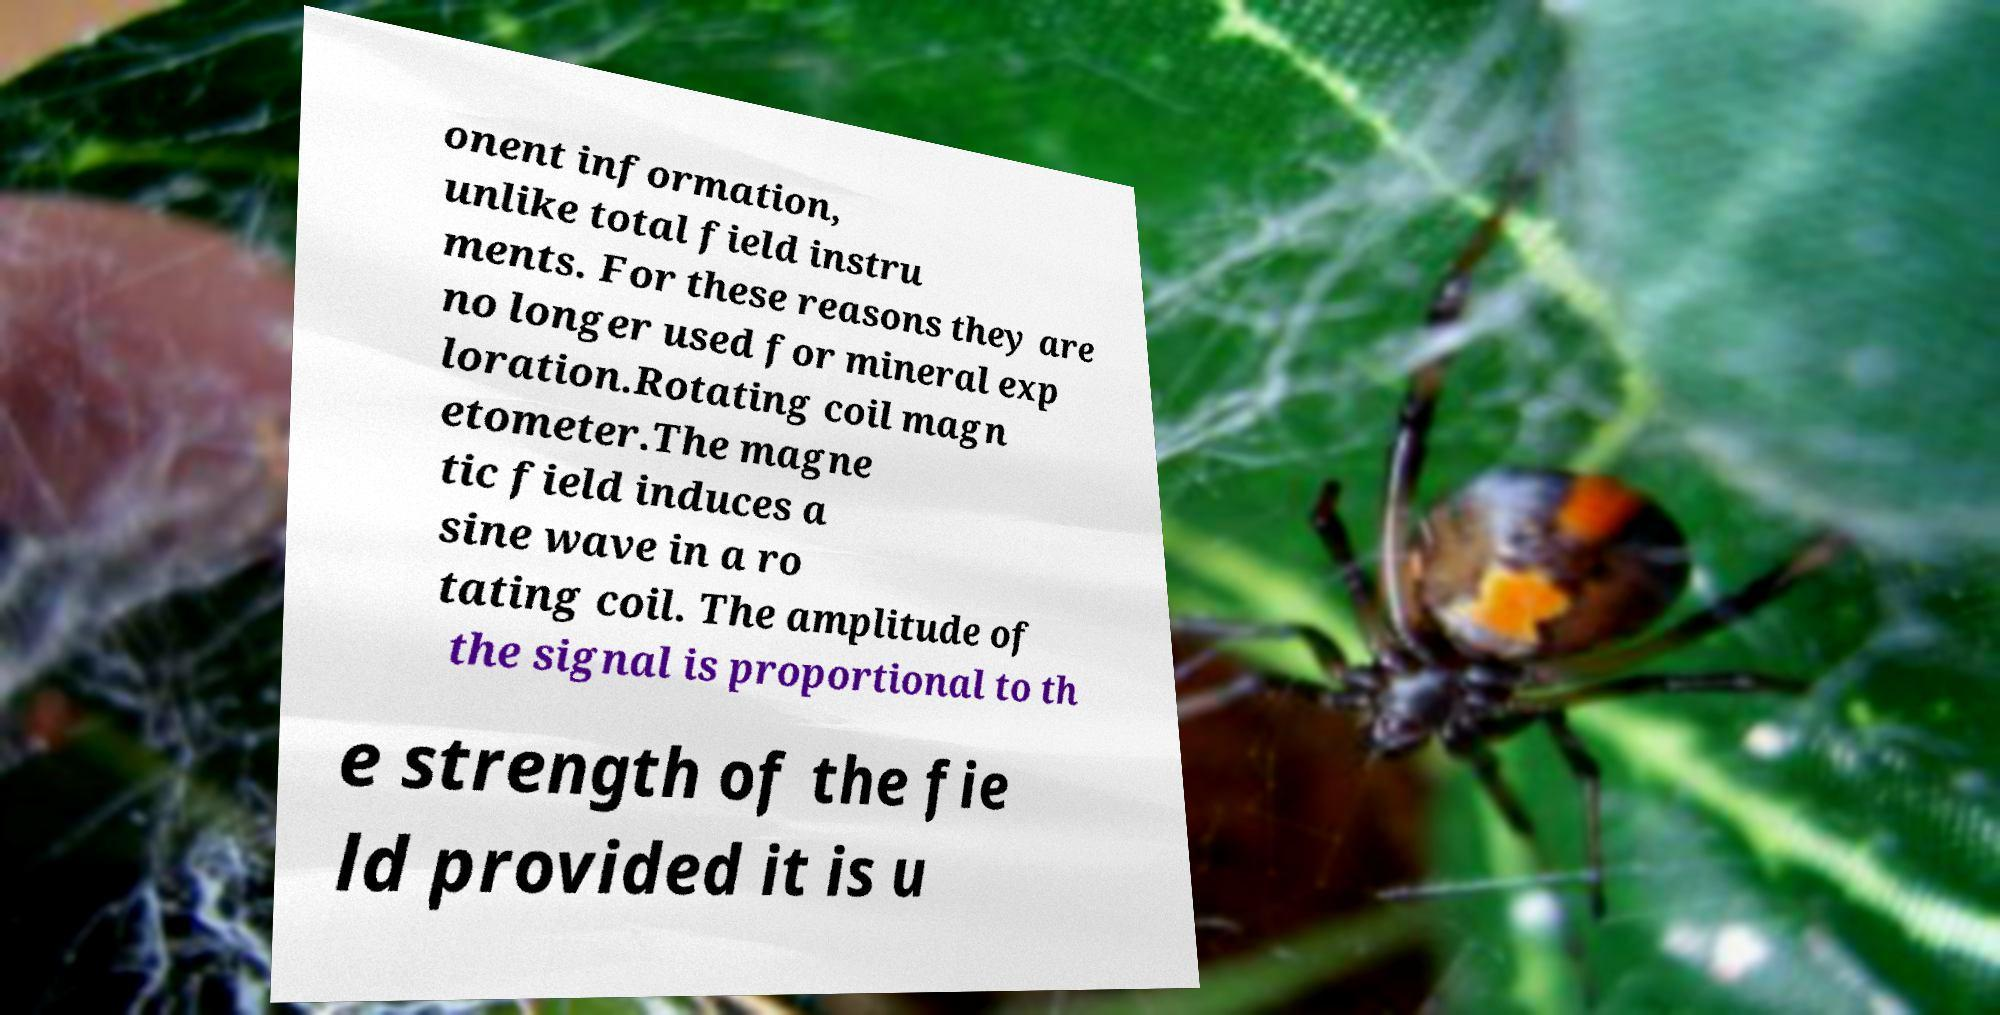Could you extract and type out the text from this image? onent information, unlike total field instru ments. For these reasons they are no longer used for mineral exp loration.Rotating coil magn etometer.The magne tic field induces a sine wave in a ro tating coil. The amplitude of the signal is proportional to th e strength of the fie ld provided it is u 